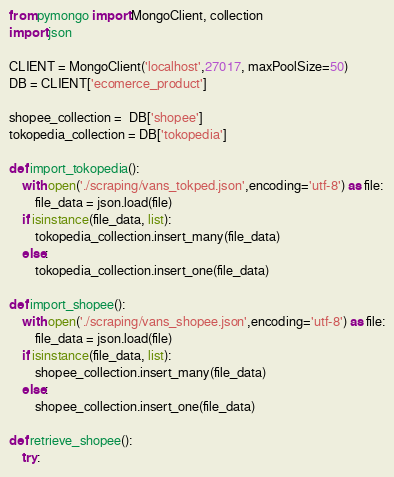<code> <loc_0><loc_0><loc_500><loc_500><_Python_>from pymongo import MongoClient, collection
import json

CLIENT = MongoClient('localhost',27017, maxPoolSize=50)
DB = CLIENT['ecomerce_product']

shopee_collection =  DB['shopee']
tokopedia_collection = DB['tokopedia']

def import_tokopedia():
    with open('./scraping/vans_tokped.json',encoding='utf-8') as file:
        file_data = json.load(file)
    if isinstance(file_data, list):
        tokopedia_collection.insert_many(file_data)
    else:
        tokopedia_collection.insert_one(file_data)

def import_shopee():
    with open('./scraping/vans_shopee.json',encoding='utf-8') as file:
        file_data = json.load(file)
    if isinstance(file_data, list):
        shopee_collection.insert_many(file_data)
    else:
        shopee_collection.insert_one(file_data)

def retrieve_shopee():
    try:</code> 